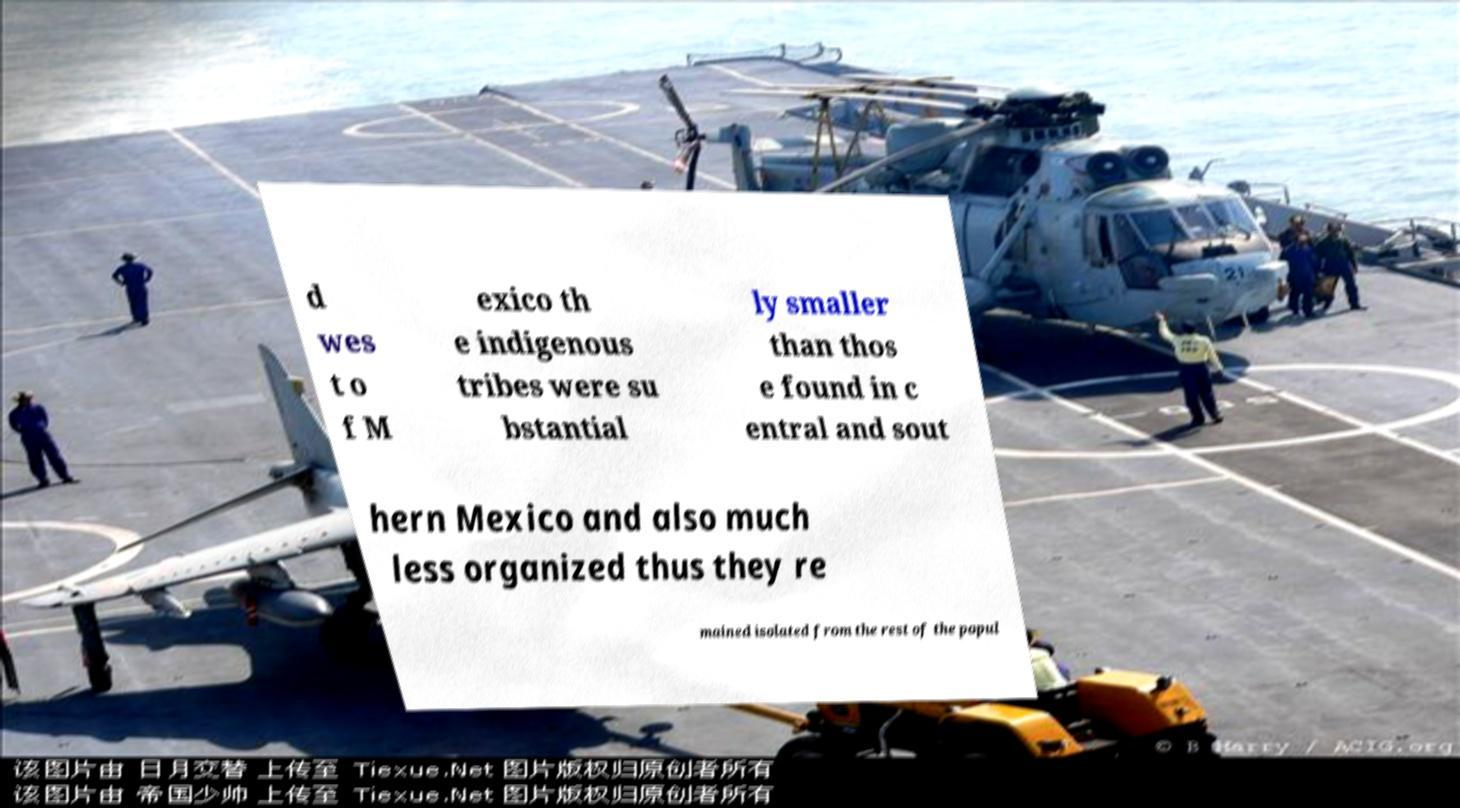Please identify and transcribe the text found in this image. d wes t o f M exico th e indigenous tribes were su bstantial ly smaller than thos e found in c entral and sout hern Mexico and also much less organized thus they re mained isolated from the rest of the popul 